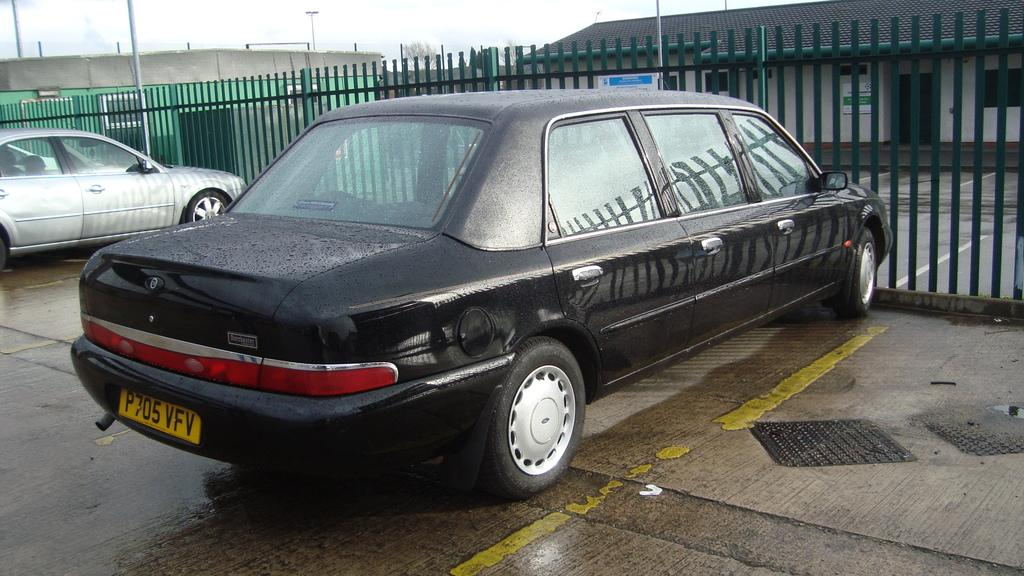What type of vehicles can be seen in the image? There are cars parked in the image. What type of structures are visible in the image? There are houses in the image. What type of objects can be seen supporting wires or signs in the image? There are poles in the image. What type of barrier can be seen in the image? There is a metal fence in the image. Can you describe the taste of the ghost in the image? There is no ghost present in the image, so it is not possible to describe its taste. 